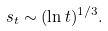<formula> <loc_0><loc_0><loc_500><loc_500>s _ { t } \sim ( \ln t ) ^ { 1 / 3 } .</formula> 